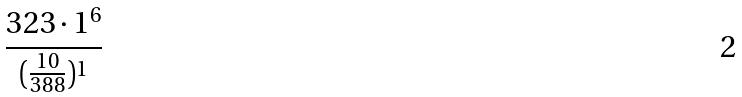Convert formula to latex. <formula><loc_0><loc_0><loc_500><loc_500>\frac { 3 2 3 \cdot 1 ^ { 6 } } { ( \frac { 1 0 } { 3 8 8 } ) ^ { 1 } }</formula> 